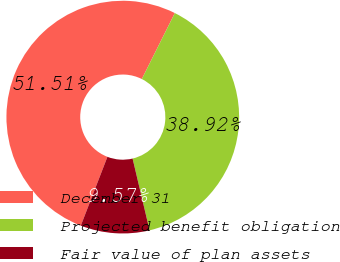<chart> <loc_0><loc_0><loc_500><loc_500><pie_chart><fcel>December 31<fcel>Projected benefit obligation<fcel>Fair value of plan assets<nl><fcel>51.51%<fcel>38.92%<fcel>9.57%<nl></chart> 